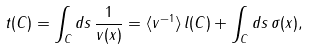Convert formula to latex. <formula><loc_0><loc_0><loc_500><loc_500>t ( C ) = \int _ { C } d s \, \frac { 1 } { v ( x ) } = \langle v ^ { - 1 } \rangle \, l ( C ) + \int _ { C } d s \, \sigma ( x ) ,</formula> 